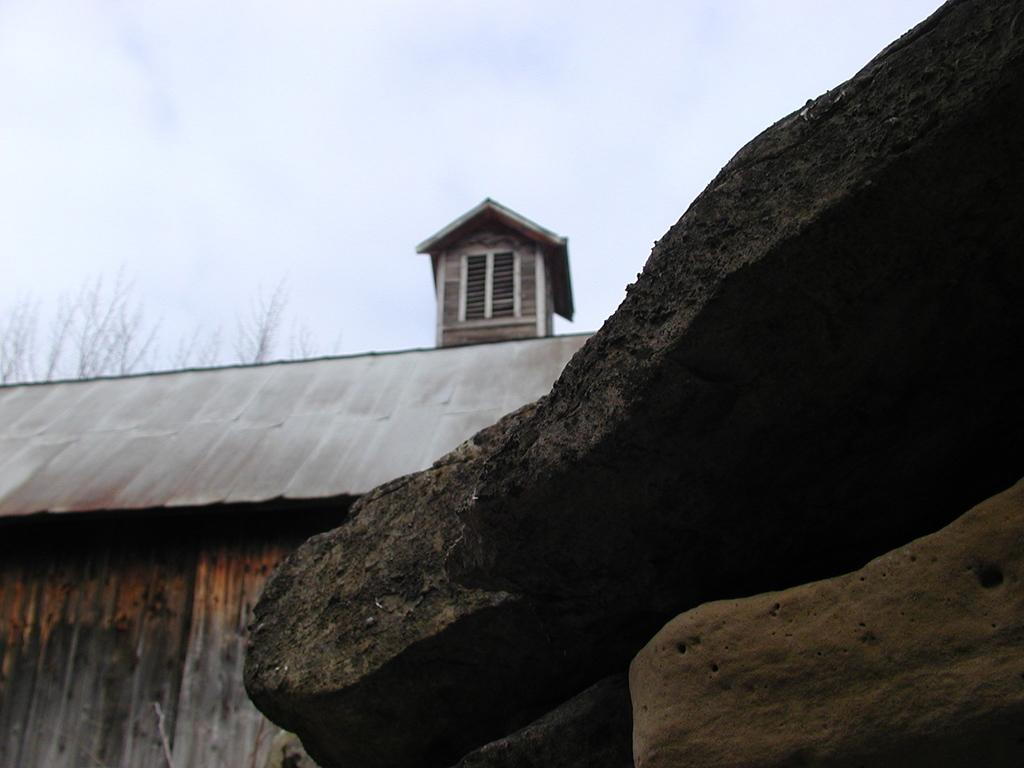What type of natural formation can be seen in the right corner of the image? There are rocks in the right corner of the image. What type of structure is located in the left corner of the image? There is a wooden house in the left corner of the image. What feature is present above the wooden house? There is a chimney above the wooden house. What is the condition of the sky in the image? The sky is cloudy in the image. What type of trousers are hanging on the clothesline in the image? There are no trousers or clothesline present in the image. Can you tell me how the request for a new chimney is being made in the image? There is no request being made in the image; it simply shows a wooden house with a chimney. 